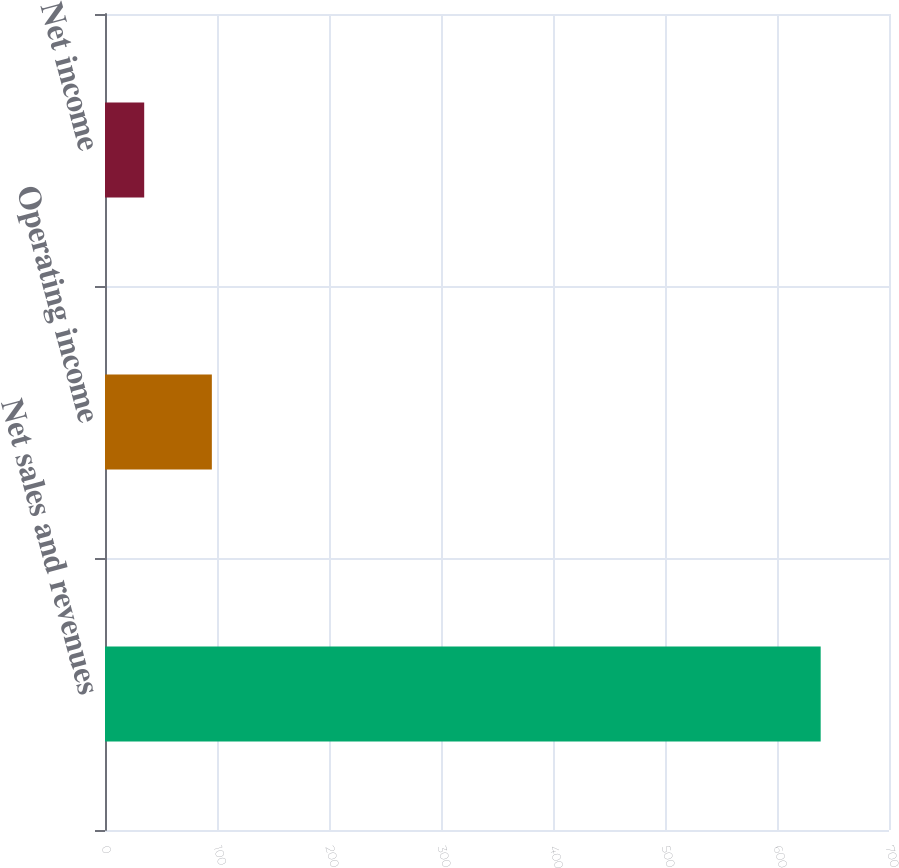<chart> <loc_0><loc_0><loc_500><loc_500><bar_chart><fcel>Net sales and revenues<fcel>Operating income<fcel>Net income<nl><fcel>639<fcel>95.4<fcel>35<nl></chart> 